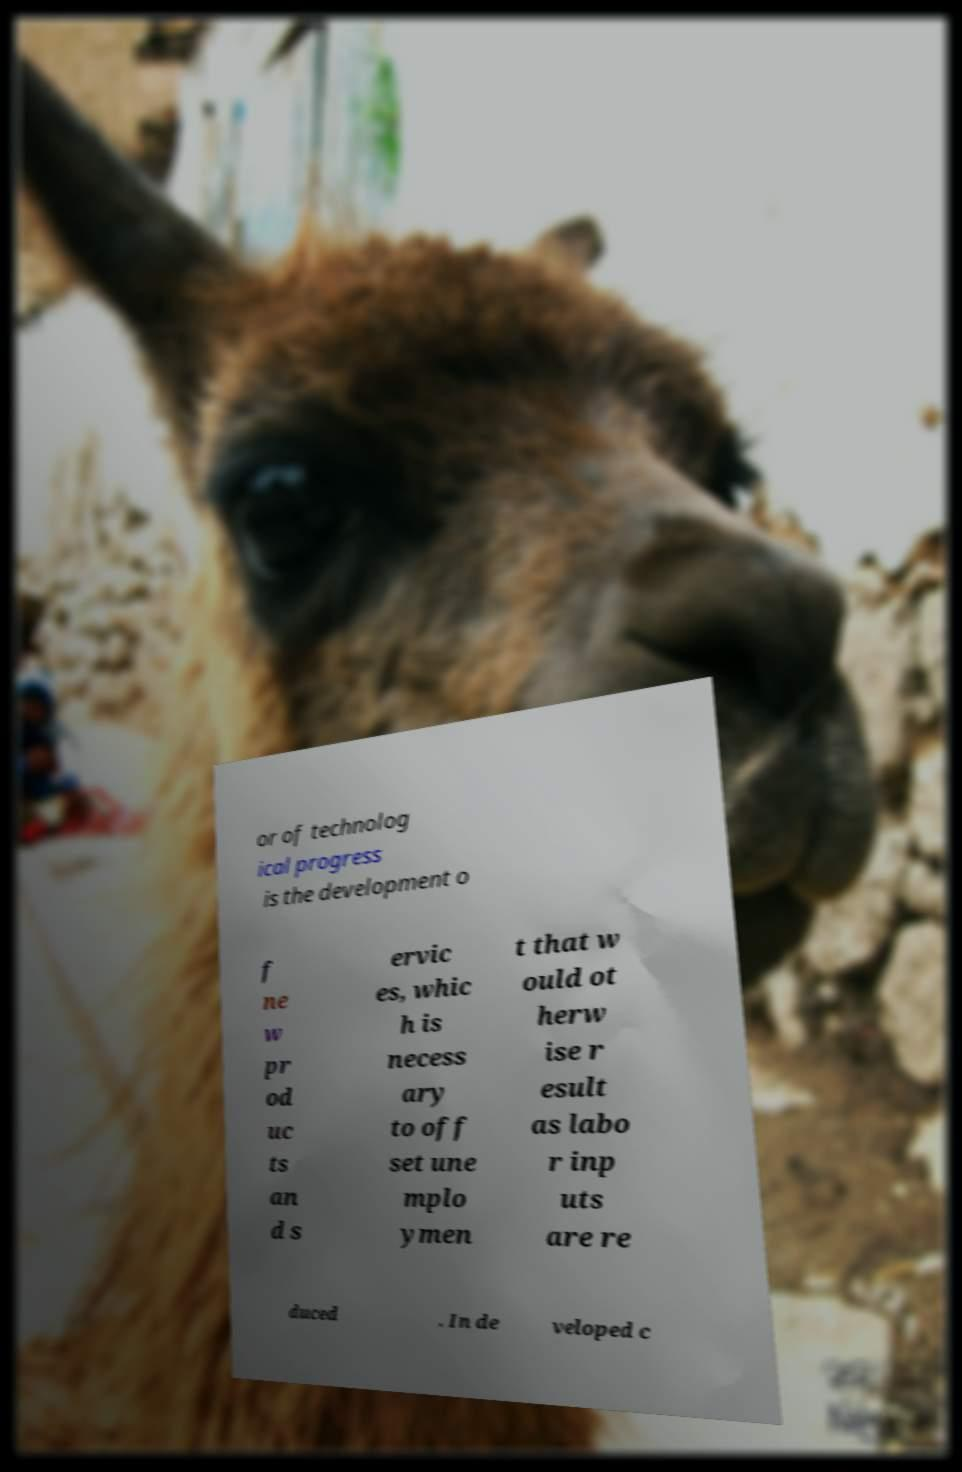Can you read and provide the text displayed in the image?This photo seems to have some interesting text. Can you extract and type it out for me? or of technolog ical progress is the development o f ne w pr od uc ts an d s ervic es, whic h is necess ary to off set une mplo ymen t that w ould ot herw ise r esult as labo r inp uts are re duced . In de veloped c 